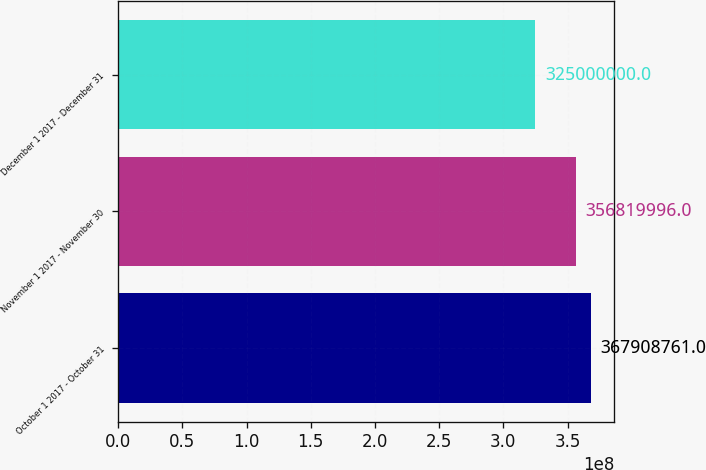<chart> <loc_0><loc_0><loc_500><loc_500><bar_chart><fcel>October 1 2017 - October 31<fcel>November 1 2017 - November 30<fcel>December 1 2017 - December 31<nl><fcel>3.67909e+08<fcel>3.5682e+08<fcel>3.25e+08<nl></chart> 